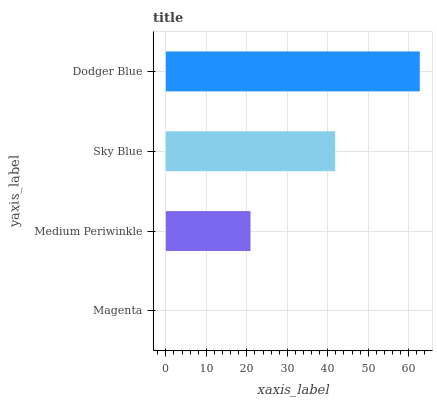Is Magenta the minimum?
Answer yes or no. Yes. Is Dodger Blue the maximum?
Answer yes or no. Yes. Is Medium Periwinkle the minimum?
Answer yes or no. No. Is Medium Periwinkle the maximum?
Answer yes or no. No. Is Medium Periwinkle greater than Magenta?
Answer yes or no. Yes. Is Magenta less than Medium Periwinkle?
Answer yes or no. Yes. Is Magenta greater than Medium Periwinkle?
Answer yes or no. No. Is Medium Periwinkle less than Magenta?
Answer yes or no. No. Is Sky Blue the high median?
Answer yes or no. Yes. Is Medium Periwinkle the low median?
Answer yes or no. Yes. Is Magenta the high median?
Answer yes or no. No. Is Dodger Blue the low median?
Answer yes or no. No. 